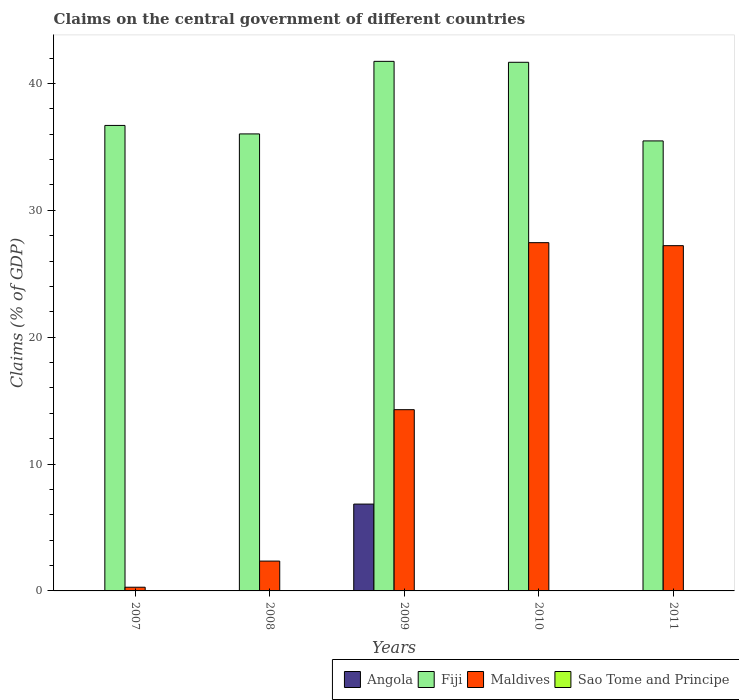Are the number of bars per tick equal to the number of legend labels?
Offer a very short reply. No. Are the number of bars on each tick of the X-axis equal?
Your answer should be very brief. No. What is the label of the 2nd group of bars from the left?
Provide a short and direct response. 2008. What is the percentage of GDP claimed on the central government in Maldives in 2010?
Offer a terse response. 27.45. Across all years, what is the maximum percentage of GDP claimed on the central government in Angola?
Your answer should be very brief. 6.84. Across all years, what is the minimum percentage of GDP claimed on the central government in Maldives?
Ensure brevity in your answer.  0.29. In which year was the percentage of GDP claimed on the central government in Maldives maximum?
Provide a short and direct response. 2010. What is the total percentage of GDP claimed on the central government in Angola in the graph?
Offer a terse response. 6.84. What is the difference between the percentage of GDP claimed on the central government in Fiji in 2007 and that in 2010?
Offer a very short reply. -4.98. What is the difference between the percentage of GDP claimed on the central government in Angola in 2010 and the percentage of GDP claimed on the central government in Fiji in 2009?
Give a very brief answer. -41.74. In the year 2010, what is the difference between the percentage of GDP claimed on the central government in Maldives and percentage of GDP claimed on the central government in Fiji?
Offer a terse response. -14.22. What is the ratio of the percentage of GDP claimed on the central government in Fiji in 2009 to that in 2011?
Provide a succinct answer. 1.18. What is the difference between the highest and the second highest percentage of GDP claimed on the central government in Maldives?
Give a very brief answer. 0.24. What is the difference between the highest and the lowest percentage of GDP claimed on the central government in Fiji?
Keep it short and to the point. 6.27. Is it the case that in every year, the sum of the percentage of GDP claimed on the central government in Angola and percentage of GDP claimed on the central government in Fiji is greater than the sum of percentage of GDP claimed on the central government in Sao Tome and Principe and percentage of GDP claimed on the central government in Maldives?
Offer a terse response. No. Is it the case that in every year, the sum of the percentage of GDP claimed on the central government in Sao Tome and Principe and percentage of GDP claimed on the central government in Angola is greater than the percentage of GDP claimed on the central government in Fiji?
Give a very brief answer. No. Are all the bars in the graph horizontal?
Make the answer very short. No. How many years are there in the graph?
Offer a terse response. 5. What is the difference between two consecutive major ticks on the Y-axis?
Give a very brief answer. 10. How many legend labels are there?
Make the answer very short. 4. How are the legend labels stacked?
Give a very brief answer. Horizontal. What is the title of the graph?
Offer a very short reply. Claims on the central government of different countries. Does "San Marino" appear as one of the legend labels in the graph?
Make the answer very short. No. What is the label or title of the X-axis?
Keep it short and to the point. Years. What is the label or title of the Y-axis?
Make the answer very short. Claims (% of GDP). What is the Claims (% of GDP) in Angola in 2007?
Ensure brevity in your answer.  0. What is the Claims (% of GDP) of Fiji in 2007?
Your response must be concise. 36.69. What is the Claims (% of GDP) in Maldives in 2007?
Provide a succinct answer. 0.29. What is the Claims (% of GDP) in Sao Tome and Principe in 2007?
Your answer should be very brief. 0. What is the Claims (% of GDP) in Fiji in 2008?
Keep it short and to the point. 36.02. What is the Claims (% of GDP) in Maldives in 2008?
Ensure brevity in your answer.  2.35. What is the Claims (% of GDP) in Sao Tome and Principe in 2008?
Provide a short and direct response. 0. What is the Claims (% of GDP) in Angola in 2009?
Provide a succinct answer. 6.84. What is the Claims (% of GDP) in Fiji in 2009?
Your answer should be very brief. 41.74. What is the Claims (% of GDP) in Maldives in 2009?
Provide a succinct answer. 14.29. What is the Claims (% of GDP) in Fiji in 2010?
Provide a short and direct response. 41.67. What is the Claims (% of GDP) in Maldives in 2010?
Your response must be concise. 27.45. What is the Claims (% of GDP) in Sao Tome and Principe in 2010?
Offer a terse response. 0. What is the Claims (% of GDP) of Angola in 2011?
Your answer should be very brief. 0. What is the Claims (% of GDP) in Fiji in 2011?
Provide a succinct answer. 35.47. What is the Claims (% of GDP) in Maldives in 2011?
Your answer should be compact. 27.22. Across all years, what is the maximum Claims (% of GDP) in Angola?
Your response must be concise. 6.84. Across all years, what is the maximum Claims (% of GDP) of Fiji?
Your response must be concise. 41.74. Across all years, what is the maximum Claims (% of GDP) of Maldives?
Ensure brevity in your answer.  27.45. Across all years, what is the minimum Claims (% of GDP) in Angola?
Your response must be concise. 0. Across all years, what is the minimum Claims (% of GDP) in Fiji?
Your response must be concise. 35.47. Across all years, what is the minimum Claims (% of GDP) in Maldives?
Provide a succinct answer. 0.29. What is the total Claims (% of GDP) of Angola in the graph?
Provide a succinct answer. 6.84. What is the total Claims (% of GDP) in Fiji in the graph?
Provide a short and direct response. 191.6. What is the total Claims (% of GDP) in Maldives in the graph?
Offer a very short reply. 71.6. What is the difference between the Claims (% of GDP) of Fiji in 2007 and that in 2008?
Make the answer very short. 0.67. What is the difference between the Claims (% of GDP) of Maldives in 2007 and that in 2008?
Make the answer very short. -2.06. What is the difference between the Claims (% of GDP) of Fiji in 2007 and that in 2009?
Ensure brevity in your answer.  -5.05. What is the difference between the Claims (% of GDP) in Maldives in 2007 and that in 2009?
Provide a short and direct response. -14. What is the difference between the Claims (% of GDP) of Fiji in 2007 and that in 2010?
Your answer should be compact. -4.98. What is the difference between the Claims (% of GDP) in Maldives in 2007 and that in 2010?
Make the answer very short. -27.16. What is the difference between the Claims (% of GDP) of Fiji in 2007 and that in 2011?
Provide a short and direct response. 1.22. What is the difference between the Claims (% of GDP) in Maldives in 2007 and that in 2011?
Make the answer very short. -26.92. What is the difference between the Claims (% of GDP) of Fiji in 2008 and that in 2009?
Make the answer very short. -5.72. What is the difference between the Claims (% of GDP) of Maldives in 2008 and that in 2009?
Your answer should be compact. -11.94. What is the difference between the Claims (% of GDP) of Fiji in 2008 and that in 2010?
Offer a terse response. -5.65. What is the difference between the Claims (% of GDP) of Maldives in 2008 and that in 2010?
Ensure brevity in your answer.  -25.1. What is the difference between the Claims (% of GDP) in Fiji in 2008 and that in 2011?
Offer a terse response. 0.55. What is the difference between the Claims (% of GDP) of Maldives in 2008 and that in 2011?
Offer a terse response. -24.86. What is the difference between the Claims (% of GDP) in Fiji in 2009 and that in 2010?
Your response must be concise. 0.07. What is the difference between the Claims (% of GDP) in Maldives in 2009 and that in 2010?
Provide a short and direct response. -13.16. What is the difference between the Claims (% of GDP) in Fiji in 2009 and that in 2011?
Provide a short and direct response. 6.27. What is the difference between the Claims (% of GDP) in Maldives in 2009 and that in 2011?
Your answer should be very brief. -12.93. What is the difference between the Claims (% of GDP) in Fiji in 2010 and that in 2011?
Offer a terse response. 6.2. What is the difference between the Claims (% of GDP) in Maldives in 2010 and that in 2011?
Provide a short and direct response. 0.24. What is the difference between the Claims (% of GDP) in Fiji in 2007 and the Claims (% of GDP) in Maldives in 2008?
Provide a short and direct response. 34.34. What is the difference between the Claims (% of GDP) of Fiji in 2007 and the Claims (% of GDP) of Maldives in 2009?
Offer a very short reply. 22.41. What is the difference between the Claims (% of GDP) in Fiji in 2007 and the Claims (% of GDP) in Maldives in 2010?
Ensure brevity in your answer.  9.24. What is the difference between the Claims (% of GDP) of Fiji in 2007 and the Claims (% of GDP) of Maldives in 2011?
Offer a very short reply. 9.48. What is the difference between the Claims (% of GDP) of Fiji in 2008 and the Claims (% of GDP) of Maldives in 2009?
Your answer should be compact. 21.74. What is the difference between the Claims (% of GDP) in Fiji in 2008 and the Claims (% of GDP) in Maldives in 2010?
Keep it short and to the point. 8.57. What is the difference between the Claims (% of GDP) in Fiji in 2008 and the Claims (% of GDP) in Maldives in 2011?
Keep it short and to the point. 8.81. What is the difference between the Claims (% of GDP) of Angola in 2009 and the Claims (% of GDP) of Fiji in 2010?
Offer a terse response. -34.83. What is the difference between the Claims (% of GDP) of Angola in 2009 and the Claims (% of GDP) of Maldives in 2010?
Your answer should be very brief. -20.61. What is the difference between the Claims (% of GDP) of Fiji in 2009 and the Claims (% of GDP) of Maldives in 2010?
Offer a very short reply. 14.29. What is the difference between the Claims (% of GDP) in Angola in 2009 and the Claims (% of GDP) in Fiji in 2011?
Keep it short and to the point. -28.63. What is the difference between the Claims (% of GDP) of Angola in 2009 and the Claims (% of GDP) of Maldives in 2011?
Make the answer very short. -20.37. What is the difference between the Claims (% of GDP) in Fiji in 2009 and the Claims (% of GDP) in Maldives in 2011?
Provide a short and direct response. 14.53. What is the difference between the Claims (% of GDP) of Fiji in 2010 and the Claims (% of GDP) of Maldives in 2011?
Your answer should be compact. 14.46. What is the average Claims (% of GDP) in Angola per year?
Give a very brief answer. 1.37. What is the average Claims (% of GDP) of Fiji per year?
Offer a very short reply. 38.32. What is the average Claims (% of GDP) of Maldives per year?
Ensure brevity in your answer.  14.32. What is the average Claims (% of GDP) in Sao Tome and Principe per year?
Provide a succinct answer. 0. In the year 2007, what is the difference between the Claims (% of GDP) of Fiji and Claims (% of GDP) of Maldives?
Your answer should be compact. 36.4. In the year 2008, what is the difference between the Claims (% of GDP) in Fiji and Claims (% of GDP) in Maldives?
Provide a short and direct response. 33.67. In the year 2009, what is the difference between the Claims (% of GDP) of Angola and Claims (% of GDP) of Fiji?
Keep it short and to the point. -34.9. In the year 2009, what is the difference between the Claims (% of GDP) of Angola and Claims (% of GDP) of Maldives?
Ensure brevity in your answer.  -7.44. In the year 2009, what is the difference between the Claims (% of GDP) in Fiji and Claims (% of GDP) in Maldives?
Provide a succinct answer. 27.46. In the year 2010, what is the difference between the Claims (% of GDP) of Fiji and Claims (% of GDP) of Maldives?
Make the answer very short. 14.22. In the year 2011, what is the difference between the Claims (% of GDP) of Fiji and Claims (% of GDP) of Maldives?
Offer a very short reply. 8.26. What is the ratio of the Claims (% of GDP) of Fiji in 2007 to that in 2008?
Give a very brief answer. 1.02. What is the ratio of the Claims (% of GDP) in Maldives in 2007 to that in 2008?
Provide a short and direct response. 0.12. What is the ratio of the Claims (% of GDP) of Fiji in 2007 to that in 2009?
Your response must be concise. 0.88. What is the ratio of the Claims (% of GDP) in Maldives in 2007 to that in 2009?
Provide a short and direct response. 0.02. What is the ratio of the Claims (% of GDP) in Fiji in 2007 to that in 2010?
Your response must be concise. 0.88. What is the ratio of the Claims (% of GDP) in Maldives in 2007 to that in 2010?
Your answer should be very brief. 0.01. What is the ratio of the Claims (% of GDP) in Fiji in 2007 to that in 2011?
Keep it short and to the point. 1.03. What is the ratio of the Claims (% of GDP) in Maldives in 2007 to that in 2011?
Provide a succinct answer. 0.01. What is the ratio of the Claims (% of GDP) in Fiji in 2008 to that in 2009?
Offer a very short reply. 0.86. What is the ratio of the Claims (% of GDP) in Maldives in 2008 to that in 2009?
Your response must be concise. 0.16. What is the ratio of the Claims (% of GDP) of Fiji in 2008 to that in 2010?
Ensure brevity in your answer.  0.86. What is the ratio of the Claims (% of GDP) of Maldives in 2008 to that in 2010?
Ensure brevity in your answer.  0.09. What is the ratio of the Claims (% of GDP) in Fiji in 2008 to that in 2011?
Provide a short and direct response. 1.02. What is the ratio of the Claims (% of GDP) in Maldives in 2008 to that in 2011?
Your answer should be very brief. 0.09. What is the ratio of the Claims (% of GDP) in Maldives in 2009 to that in 2010?
Your answer should be compact. 0.52. What is the ratio of the Claims (% of GDP) of Fiji in 2009 to that in 2011?
Provide a succinct answer. 1.18. What is the ratio of the Claims (% of GDP) of Maldives in 2009 to that in 2011?
Give a very brief answer. 0.53. What is the ratio of the Claims (% of GDP) in Fiji in 2010 to that in 2011?
Give a very brief answer. 1.17. What is the ratio of the Claims (% of GDP) in Maldives in 2010 to that in 2011?
Make the answer very short. 1.01. What is the difference between the highest and the second highest Claims (% of GDP) of Fiji?
Keep it short and to the point. 0.07. What is the difference between the highest and the second highest Claims (% of GDP) of Maldives?
Offer a terse response. 0.24. What is the difference between the highest and the lowest Claims (% of GDP) in Angola?
Offer a very short reply. 6.84. What is the difference between the highest and the lowest Claims (% of GDP) in Fiji?
Make the answer very short. 6.27. What is the difference between the highest and the lowest Claims (% of GDP) of Maldives?
Offer a very short reply. 27.16. 